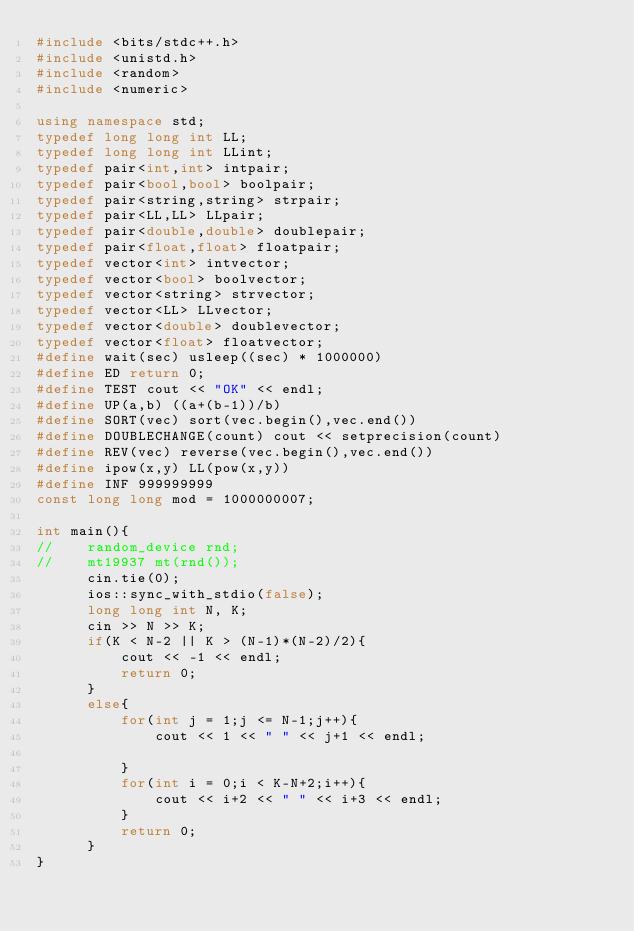<code> <loc_0><loc_0><loc_500><loc_500><_C++_>#include <bits/stdc++.h>
#include <unistd.h>
#include <random>
#include <numeric>

using namespace std;
typedef long long int LL;
typedef long long int LLint;
typedef pair<int,int> intpair;
typedef pair<bool,bool> boolpair;
typedef pair<string,string> strpair;
typedef pair<LL,LL> LLpair;
typedef pair<double,double> doublepair;
typedef pair<float,float> floatpair;
typedef vector<int> intvector;
typedef vector<bool> boolvector;
typedef vector<string> strvector;
typedef vector<LL> LLvector;
typedef vector<double> doublevector;
typedef vector<float> floatvector;
#define wait(sec) usleep((sec) * 1000000)
#define ED return 0;
#define TEST cout << "OK" << endl;
#define UP(a,b) ((a+(b-1))/b)
#define SORT(vec) sort(vec.begin(),vec.end())
#define DOUBLECHANGE(count) cout << setprecision(count)
#define REV(vec) reverse(vec.begin(),vec.end())
#define ipow(x,y) LL(pow(x,y))
#define INF 999999999
const long long mod = 1000000007;

int main(){
//    random_device rnd;
//    mt19937 mt(rnd());
      cin.tie(0);
      ios::sync_with_stdio(false);
      long long int N, K;
      cin >> N >> K;
      if(K < N-2 || K > (N-1)*(N-2)/2){
          cout << -1 << endl;
          return 0;
      }
      else{
          for(int j = 1;j <= N-1;j++){
              cout << 1 << " " << j+1 << endl;
              
          }
          for(int i = 0;i < K-N+2;i++){
              cout << i+2 << " " << i+3 << endl;
          }
          return 0;
      }
}
</code> 